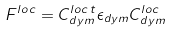Convert formula to latex. <formula><loc_0><loc_0><loc_500><loc_500>F ^ { l o c } = C _ { d y m } ^ { l o c \, t } \epsilon _ { d y m } C _ { d y m } ^ { l o c }</formula> 